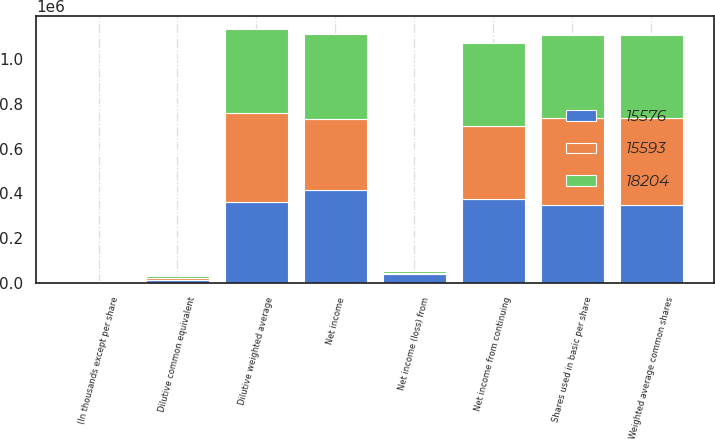<chart> <loc_0><loc_0><loc_500><loc_500><stacked_bar_chart><ecel><fcel>(In thousands except per share<fcel>Net income from continuing<fcel>Net income (loss) from<fcel>Net income<fcel>Shares used in basic per share<fcel>Weighted average common shares<fcel>Dilutive common equivalent<fcel>Dilutive weighted average<nl><fcel>15576<fcel>2006<fcel>377430<fcel>39533<fcel>416963<fcel>347854<fcel>347854<fcel>12617<fcel>360471<nl><fcel>18204<fcel>2005<fcel>374983<fcel>6644<fcel>381627<fcel>369202<fcel>369202<fcel>7594<fcel>376796<nl><fcel>15593<fcel>2004<fcel>323322<fcel>6292<fcel>317030<fcel>390910<fcel>390910<fcel>9252<fcel>400162<nl></chart> 